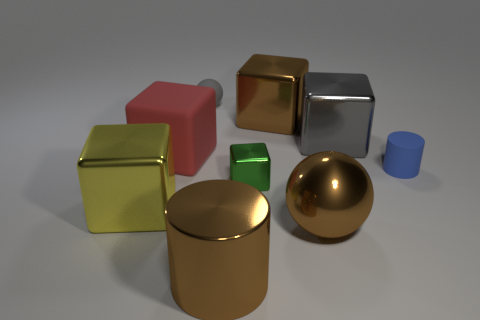The large sphere that is the same material as the big brown cylinder is what color?
Offer a terse response. Brown. Is the color of the large shiny cylinder the same as the sphere that is in front of the tiny matte cylinder?
Provide a succinct answer. Yes. There is a object that is in front of the gray ball and behind the gray block; what color is it?
Keep it short and to the point. Brown. There is a large metal ball; how many tiny cubes are in front of it?
Offer a very short reply. 0. What number of things are either big gray metal cubes or brown things that are in front of the large brown metallic block?
Provide a succinct answer. 3. There is a big brown metallic object that is behind the yellow metal block; are there any brown objects that are on the right side of it?
Give a very brief answer. Yes. There is a small object on the left side of the tiny metallic cube; what color is it?
Provide a succinct answer. Gray. Is the number of brown metallic cylinders that are right of the brown shiny ball the same as the number of shiny things?
Offer a very short reply. No. The metallic thing that is both right of the small metallic object and in front of the green metallic object has what shape?
Your answer should be compact. Sphere. What color is the small metallic object that is the same shape as the big yellow object?
Make the answer very short. Green. 